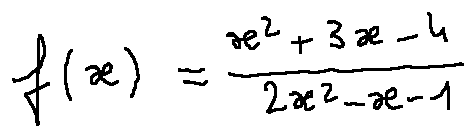Convert formula to latex. <formula><loc_0><loc_0><loc_500><loc_500>f ( x ) = \frac { x ^ { 2 } + 3 x - 4 } { 2 x ^ { 2 } - x - 1 }</formula> 